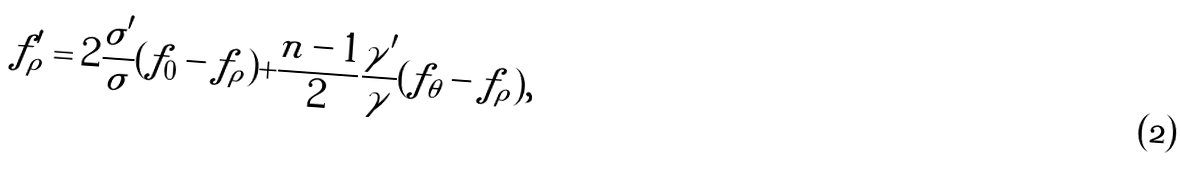<formula> <loc_0><loc_0><loc_500><loc_500>f _ { \rho } ^ { \prime } = 2 \frac { \sigma ^ { \prime } } { \sigma } ( f _ { 0 } - f _ { \rho } ) + \frac { n - 1 } { 2 } \frac { \gamma ^ { \prime } } { \gamma } ( f _ { \theta } - f _ { \rho } ) ,</formula> 